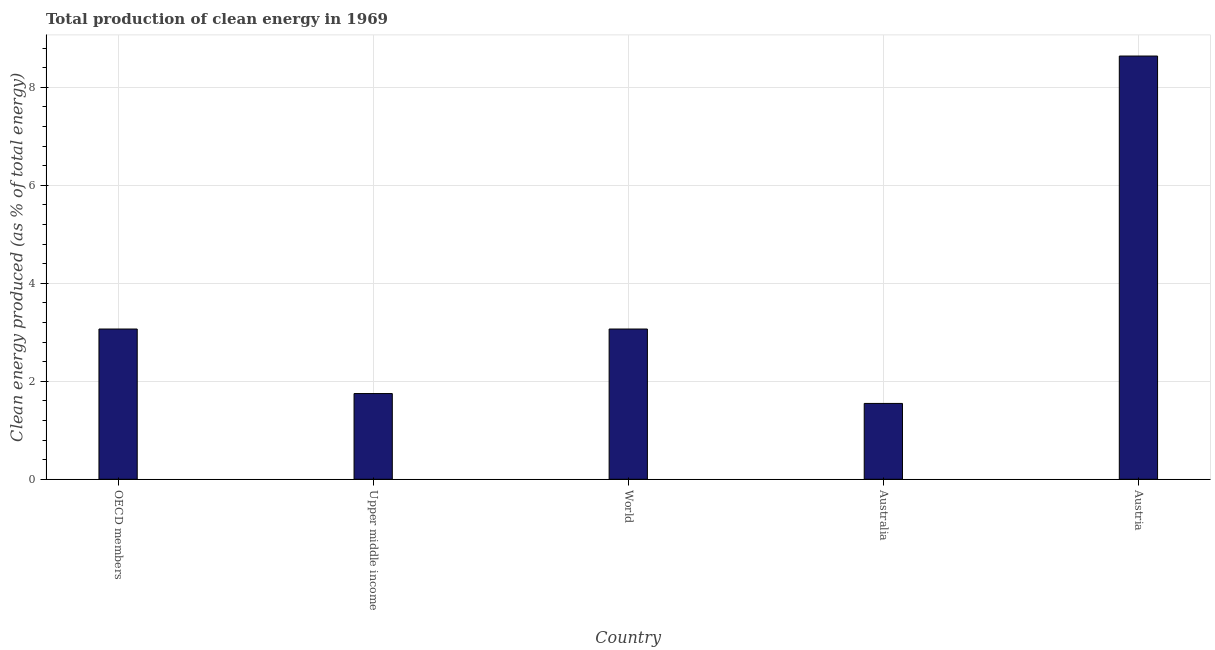Does the graph contain grids?
Give a very brief answer. Yes. What is the title of the graph?
Offer a very short reply. Total production of clean energy in 1969. What is the label or title of the X-axis?
Keep it short and to the point. Country. What is the label or title of the Y-axis?
Your answer should be compact. Clean energy produced (as % of total energy). What is the production of clean energy in Australia?
Offer a very short reply. 1.55. Across all countries, what is the maximum production of clean energy?
Your answer should be compact. 8.64. Across all countries, what is the minimum production of clean energy?
Your response must be concise. 1.55. In which country was the production of clean energy maximum?
Offer a terse response. Austria. What is the sum of the production of clean energy?
Give a very brief answer. 18.07. What is the difference between the production of clean energy in Upper middle income and World?
Provide a succinct answer. -1.32. What is the average production of clean energy per country?
Your response must be concise. 3.61. What is the median production of clean energy?
Your answer should be very brief. 3.07. In how many countries, is the production of clean energy greater than 4.8 %?
Ensure brevity in your answer.  1. What is the ratio of the production of clean energy in Australia to that in Upper middle income?
Provide a short and direct response. 0.89. Is the production of clean energy in Austria less than that in World?
Provide a succinct answer. No. Is the difference between the production of clean energy in Austria and Upper middle income greater than the difference between any two countries?
Give a very brief answer. No. What is the difference between the highest and the second highest production of clean energy?
Ensure brevity in your answer.  5.57. What is the difference between the highest and the lowest production of clean energy?
Your answer should be compact. 7.09. In how many countries, is the production of clean energy greater than the average production of clean energy taken over all countries?
Ensure brevity in your answer.  1. How many bars are there?
Ensure brevity in your answer.  5. Are all the bars in the graph horizontal?
Make the answer very short. No. What is the difference between two consecutive major ticks on the Y-axis?
Give a very brief answer. 2. Are the values on the major ticks of Y-axis written in scientific E-notation?
Provide a succinct answer. No. What is the Clean energy produced (as % of total energy) in OECD members?
Ensure brevity in your answer.  3.07. What is the Clean energy produced (as % of total energy) in Upper middle income?
Your response must be concise. 1.75. What is the Clean energy produced (as % of total energy) in World?
Keep it short and to the point. 3.07. What is the Clean energy produced (as % of total energy) in Australia?
Ensure brevity in your answer.  1.55. What is the Clean energy produced (as % of total energy) in Austria?
Give a very brief answer. 8.64. What is the difference between the Clean energy produced (as % of total energy) in OECD members and Upper middle income?
Offer a terse response. 1.32. What is the difference between the Clean energy produced (as % of total energy) in OECD members and Australia?
Offer a terse response. 1.52. What is the difference between the Clean energy produced (as % of total energy) in OECD members and Austria?
Provide a short and direct response. -5.57. What is the difference between the Clean energy produced (as % of total energy) in Upper middle income and World?
Your response must be concise. -1.32. What is the difference between the Clean energy produced (as % of total energy) in Upper middle income and Australia?
Your answer should be compact. 0.2. What is the difference between the Clean energy produced (as % of total energy) in Upper middle income and Austria?
Provide a succinct answer. -6.89. What is the difference between the Clean energy produced (as % of total energy) in World and Australia?
Ensure brevity in your answer.  1.52. What is the difference between the Clean energy produced (as % of total energy) in World and Austria?
Make the answer very short. -5.57. What is the difference between the Clean energy produced (as % of total energy) in Australia and Austria?
Give a very brief answer. -7.09. What is the ratio of the Clean energy produced (as % of total energy) in OECD members to that in Upper middle income?
Offer a terse response. 1.75. What is the ratio of the Clean energy produced (as % of total energy) in OECD members to that in Australia?
Provide a succinct answer. 1.98. What is the ratio of the Clean energy produced (as % of total energy) in OECD members to that in Austria?
Offer a terse response. 0.35. What is the ratio of the Clean energy produced (as % of total energy) in Upper middle income to that in World?
Offer a very short reply. 0.57. What is the ratio of the Clean energy produced (as % of total energy) in Upper middle income to that in Australia?
Your answer should be compact. 1.13. What is the ratio of the Clean energy produced (as % of total energy) in Upper middle income to that in Austria?
Provide a short and direct response. 0.2. What is the ratio of the Clean energy produced (as % of total energy) in World to that in Australia?
Make the answer very short. 1.98. What is the ratio of the Clean energy produced (as % of total energy) in World to that in Austria?
Offer a terse response. 0.35. What is the ratio of the Clean energy produced (as % of total energy) in Australia to that in Austria?
Provide a succinct answer. 0.18. 